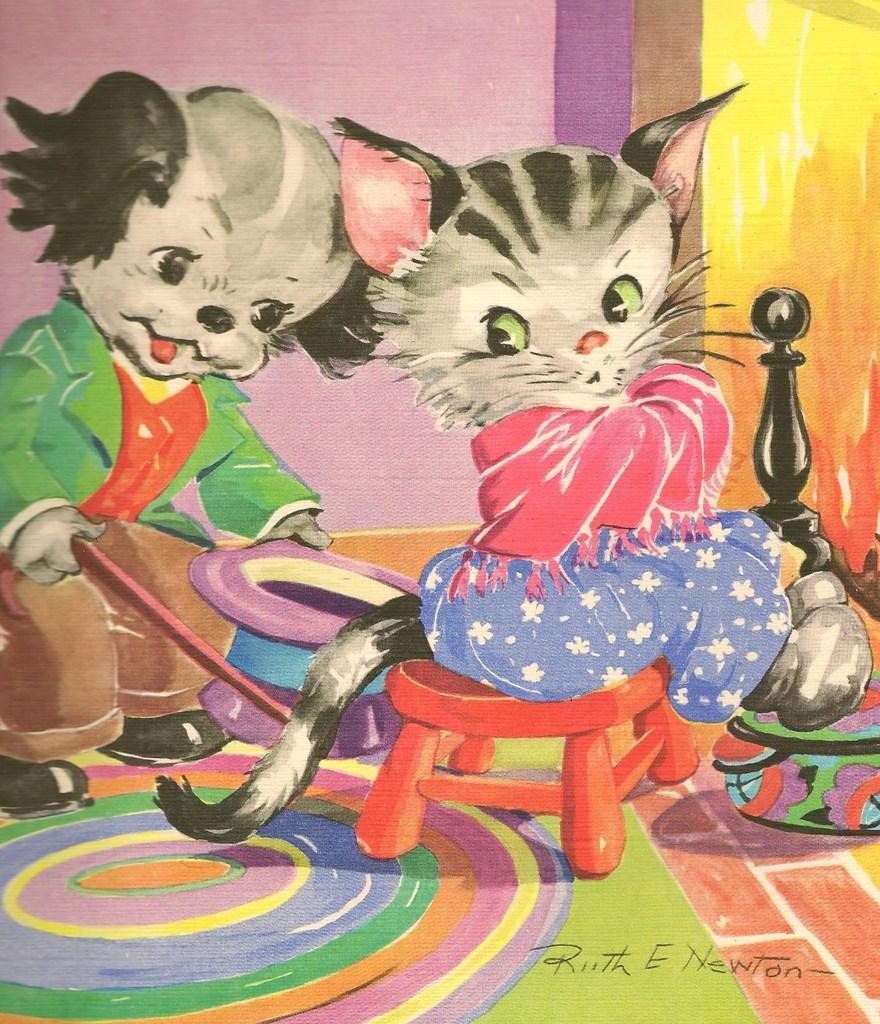What is the main subject of the painting? The main subject of the painting is two cats. Can you describe the position of the first cat in the painting? The first cat is sitting on a stool in the painting. What is the second cat doing in the painting? The second cat is standing behind the first cat and holding a cap and a stick in its hands. What is the color of the floor in the painting? The floor in the painting is colorful. What type of cabbage is being turned by the cat in the painting? There is no cabbage or turning action depicted in the painting; it features two cats, one sitting on a stool and the other standing behind it holding a cap and a stick. 